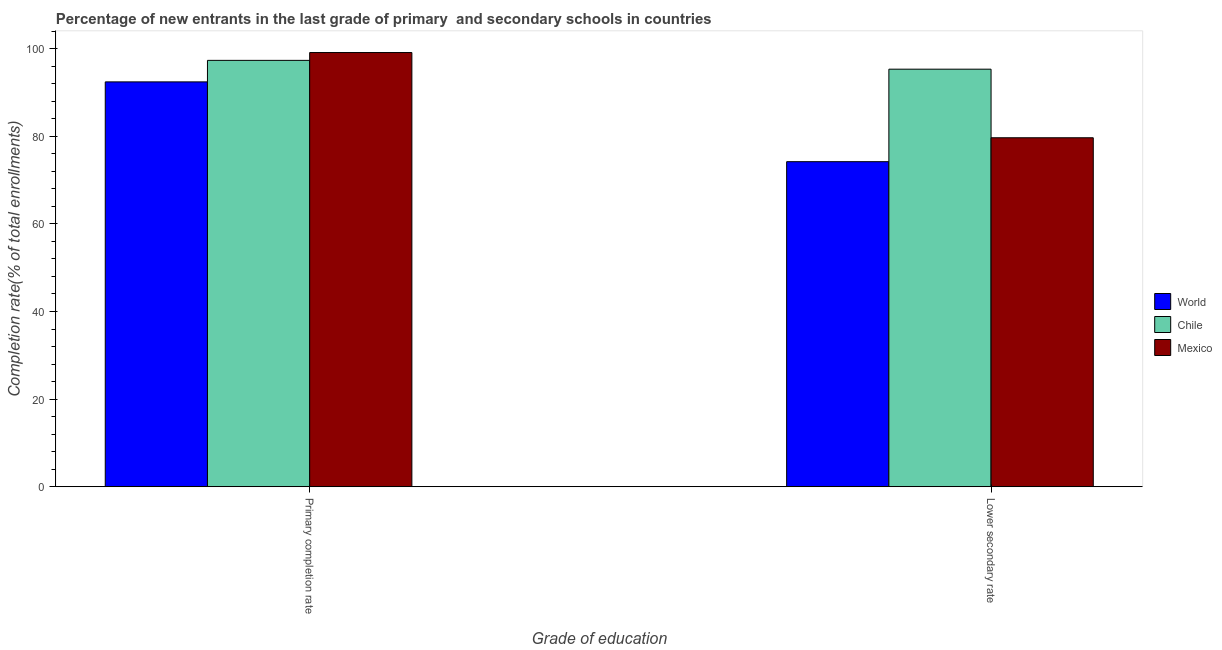How many different coloured bars are there?
Your answer should be very brief. 3. How many groups of bars are there?
Your answer should be very brief. 2. Are the number of bars on each tick of the X-axis equal?
Make the answer very short. Yes. How many bars are there on the 2nd tick from the right?
Keep it short and to the point. 3. What is the label of the 2nd group of bars from the left?
Your answer should be very brief. Lower secondary rate. What is the completion rate in secondary schools in Mexico?
Ensure brevity in your answer.  79.67. Across all countries, what is the maximum completion rate in primary schools?
Give a very brief answer. 99.12. Across all countries, what is the minimum completion rate in primary schools?
Offer a very short reply. 92.42. What is the total completion rate in primary schools in the graph?
Provide a succinct answer. 288.87. What is the difference between the completion rate in secondary schools in Mexico and that in World?
Keep it short and to the point. 5.46. What is the difference between the completion rate in primary schools in Chile and the completion rate in secondary schools in World?
Give a very brief answer. 23.13. What is the average completion rate in secondary schools per country?
Your answer should be very brief. 83.06. What is the difference between the completion rate in primary schools and completion rate in secondary schools in Mexico?
Make the answer very short. 19.46. What is the ratio of the completion rate in secondary schools in Mexico to that in World?
Your answer should be very brief. 1.07. In how many countries, is the completion rate in primary schools greater than the average completion rate in primary schools taken over all countries?
Offer a terse response. 2. What does the 2nd bar from the left in Primary completion rate represents?
Your answer should be very brief. Chile. Are all the bars in the graph horizontal?
Make the answer very short. No. Are the values on the major ticks of Y-axis written in scientific E-notation?
Provide a short and direct response. No. Where does the legend appear in the graph?
Give a very brief answer. Center right. What is the title of the graph?
Give a very brief answer. Percentage of new entrants in the last grade of primary  and secondary schools in countries. Does "Guinea" appear as one of the legend labels in the graph?
Your answer should be compact. No. What is the label or title of the X-axis?
Provide a succinct answer. Grade of education. What is the label or title of the Y-axis?
Offer a very short reply. Completion rate(% of total enrollments). What is the Completion rate(% of total enrollments) of World in Primary completion rate?
Ensure brevity in your answer.  92.42. What is the Completion rate(% of total enrollments) of Chile in Primary completion rate?
Your answer should be compact. 97.33. What is the Completion rate(% of total enrollments) of Mexico in Primary completion rate?
Your answer should be compact. 99.12. What is the Completion rate(% of total enrollments) of World in Lower secondary rate?
Your answer should be compact. 74.2. What is the Completion rate(% of total enrollments) of Chile in Lower secondary rate?
Offer a very short reply. 95.32. What is the Completion rate(% of total enrollments) of Mexico in Lower secondary rate?
Keep it short and to the point. 79.67. Across all Grade of education, what is the maximum Completion rate(% of total enrollments) of World?
Offer a very short reply. 92.42. Across all Grade of education, what is the maximum Completion rate(% of total enrollments) of Chile?
Give a very brief answer. 97.33. Across all Grade of education, what is the maximum Completion rate(% of total enrollments) of Mexico?
Offer a terse response. 99.12. Across all Grade of education, what is the minimum Completion rate(% of total enrollments) of World?
Ensure brevity in your answer.  74.2. Across all Grade of education, what is the minimum Completion rate(% of total enrollments) of Chile?
Make the answer very short. 95.32. Across all Grade of education, what is the minimum Completion rate(% of total enrollments) of Mexico?
Your answer should be very brief. 79.67. What is the total Completion rate(% of total enrollments) of World in the graph?
Make the answer very short. 166.63. What is the total Completion rate(% of total enrollments) of Chile in the graph?
Make the answer very short. 192.65. What is the total Completion rate(% of total enrollments) in Mexico in the graph?
Provide a short and direct response. 178.79. What is the difference between the Completion rate(% of total enrollments) of World in Primary completion rate and that in Lower secondary rate?
Your answer should be compact. 18.22. What is the difference between the Completion rate(% of total enrollments) in Chile in Primary completion rate and that in Lower secondary rate?
Give a very brief answer. 2.01. What is the difference between the Completion rate(% of total enrollments) in Mexico in Primary completion rate and that in Lower secondary rate?
Provide a succinct answer. 19.46. What is the difference between the Completion rate(% of total enrollments) in World in Primary completion rate and the Completion rate(% of total enrollments) in Chile in Lower secondary rate?
Make the answer very short. -2.9. What is the difference between the Completion rate(% of total enrollments) in World in Primary completion rate and the Completion rate(% of total enrollments) in Mexico in Lower secondary rate?
Make the answer very short. 12.76. What is the difference between the Completion rate(% of total enrollments) of Chile in Primary completion rate and the Completion rate(% of total enrollments) of Mexico in Lower secondary rate?
Offer a terse response. 17.67. What is the average Completion rate(% of total enrollments) in World per Grade of education?
Provide a short and direct response. 83.31. What is the average Completion rate(% of total enrollments) of Chile per Grade of education?
Your answer should be compact. 96.33. What is the average Completion rate(% of total enrollments) of Mexico per Grade of education?
Keep it short and to the point. 89.39. What is the difference between the Completion rate(% of total enrollments) of World and Completion rate(% of total enrollments) of Chile in Primary completion rate?
Your response must be concise. -4.91. What is the difference between the Completion rate(% of total enrollments) of World and Completion rate(% of total enrollments) of Mexico in Primary completion rate?
Offer a very short reply. -6.7. What is the difference between the Completion rate(% of total enrollments) of Chile and Completion rate(% of total enrollments) of Mexico in Primary completion rate?
Your answer should be very brief. -1.79. What is the difference between the Completion rate(% of total enrollments) in World and Completion rate(% of total enrollments) in Chile in Lower secondary rate?
Ensure brevity in your answer.  -21.12. What is the difference between the Completion rate(% of total enrollments) in World and Completion rate(% of total enrollments) in Mexico in Lower secondary rate?
Give a very brief answer. -5.46. What is the difference between the Completion rate(% of total enrollments) of Chile and Completion rate(% of total enrollments) of Mexico in Lower secondary rate?
Ensure brevity in your answer.  15.66. What is the ratio of the Completion rate(% of total enrollments) in World in Primary completion rate to that in Lower secondary rate?
Offer a terse response. 1.25. What is the ratio of the Completion rate(% of total enrollments) in Chile in Primary completion rate to that in Lower secondary rate?
Make the answer very short. 1.02. What is the ratio of the Completion rate(% of total enrollments) of Mexico in Primary completion rate to that in Lower secondary rate?
Your answer should be very brief. 1.24. What is the difference between the highest and the second highest Completion rate(% of total enrollments) of World?
Offer a terse response. 18.22. What is the difference between the highest and the second highest Completion rate(% of total enrollments) of Chile?
Provide a succinct answer. 2.01. What is the difference between the highest and the second highest Completion rate(% of total enrollments) in Mexico?
Provide a short and direct response. 19.46. What is the difference between the highest and the lowest Completion rate(% of total enrollments) of World?
Make the answer very short. 18.22. What is the difference between the highest and the lowest Completion rate(% of total enrollments) in Chile?
Provide a succinct answer. 2.01. What is the difference between the highest and the lowest Completion rate(% of total enrollments) of Mexico?
Your answer should be compact. 19.46. 